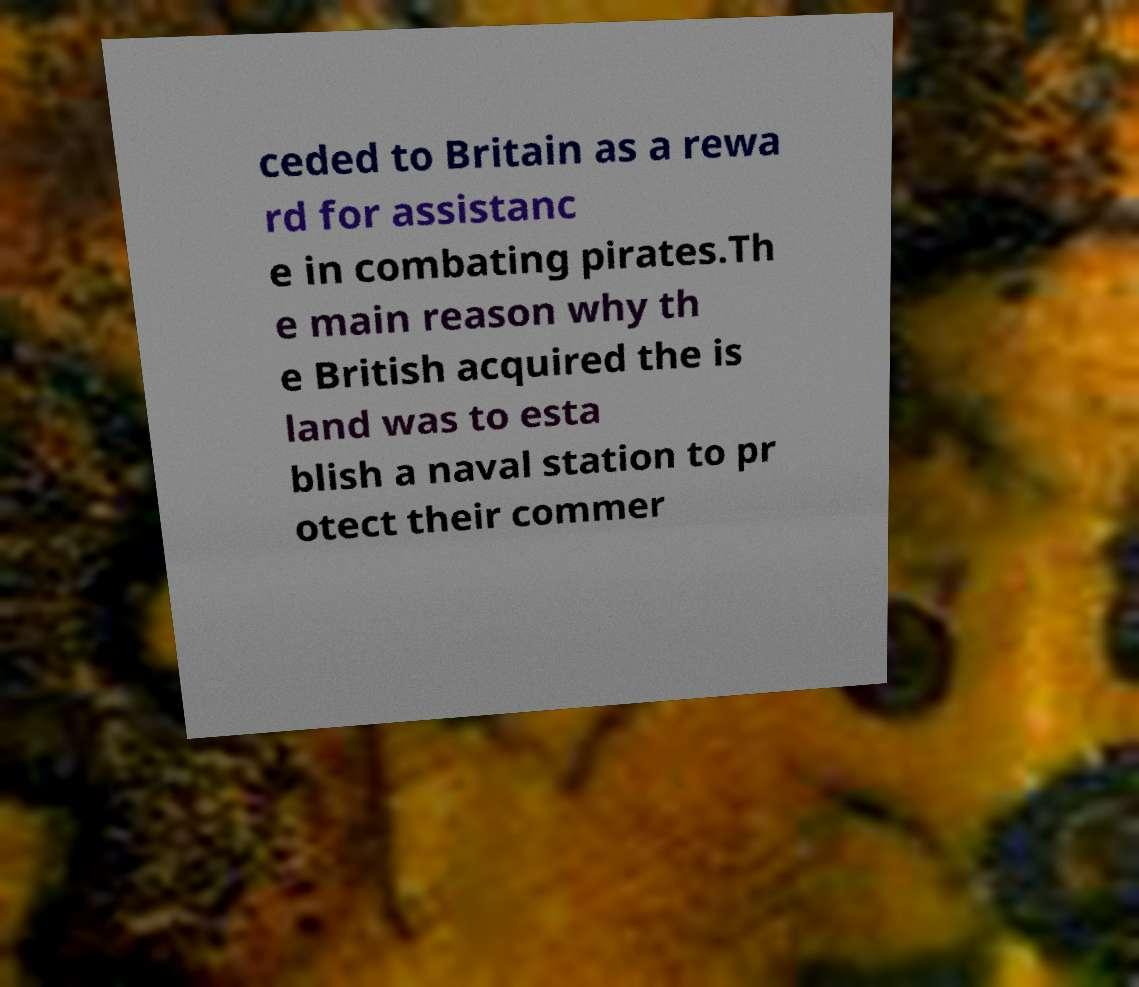Please read and relay the text visible in this image. What does it say? ceded to Britain as a rewa rd for assistanc e in combating pirates.Th e main reason why th e British acquired the is land was to esta blish a naval station to pr otect their commer 